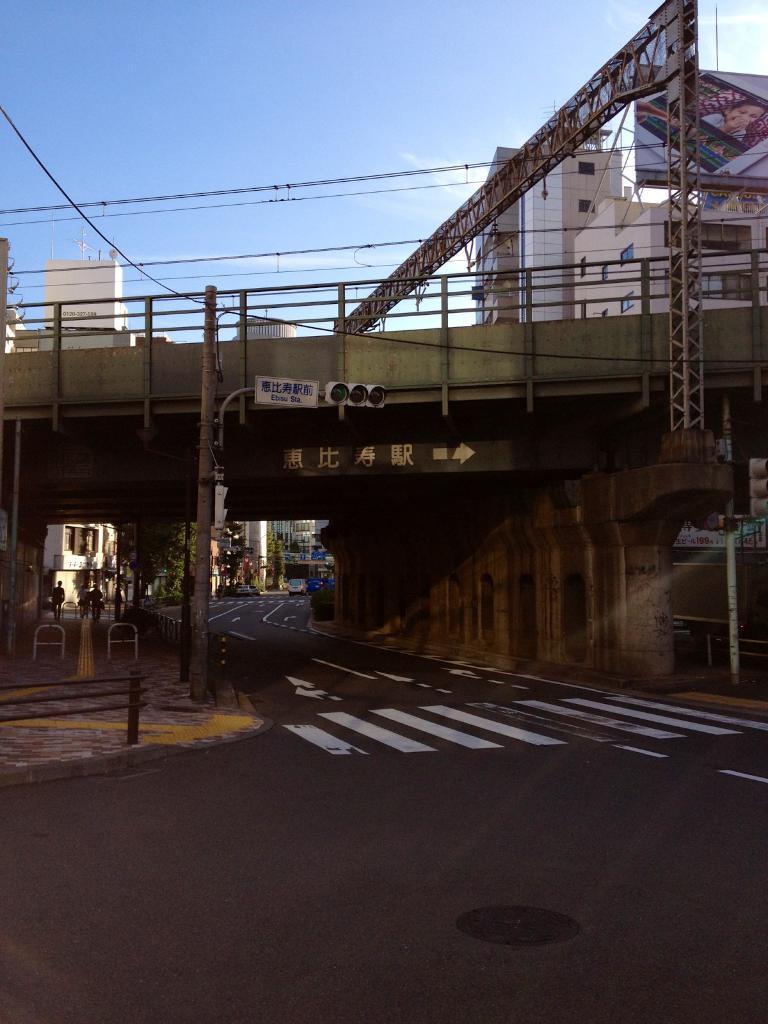Can you describe this image briefly? This image consists of a road. In the front, we can see a bridge. At the top, we can see buildings along with the hoarding and sky. 